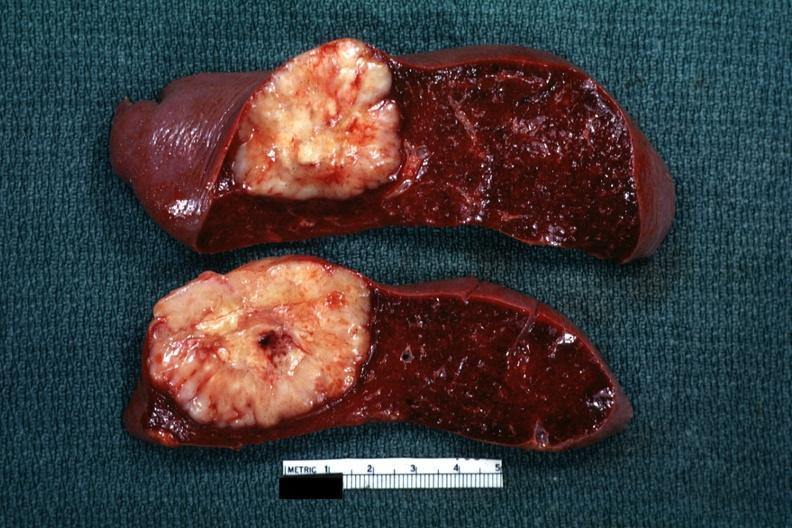s glioma quite large diagnosis was reticulum cell sarcoma?
Answer the question using a single word or phrase. No 